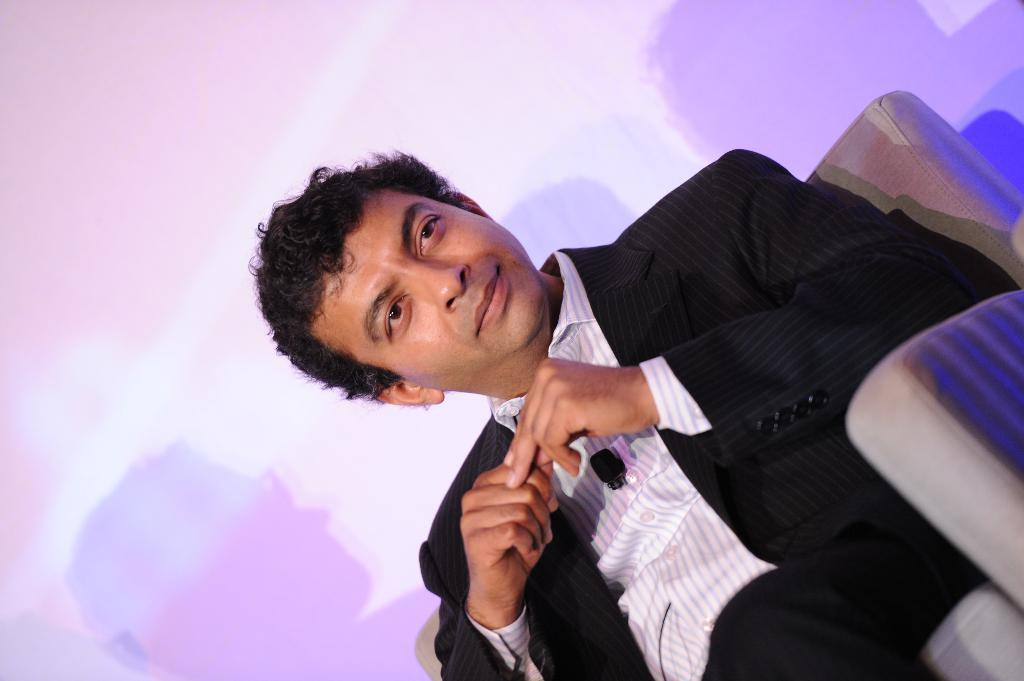What is the man in the image doing? The man is sitting in a chair in the image. What can be seen in the background of the image? There is a wall visible in the background of the image. What is unique about the wall in the image? Shadows of persons are present on the wall. What type of brain can be seen in the image? There is no brain present in the image. What is the cause of the mist in the image? There is no mist present in the image. 